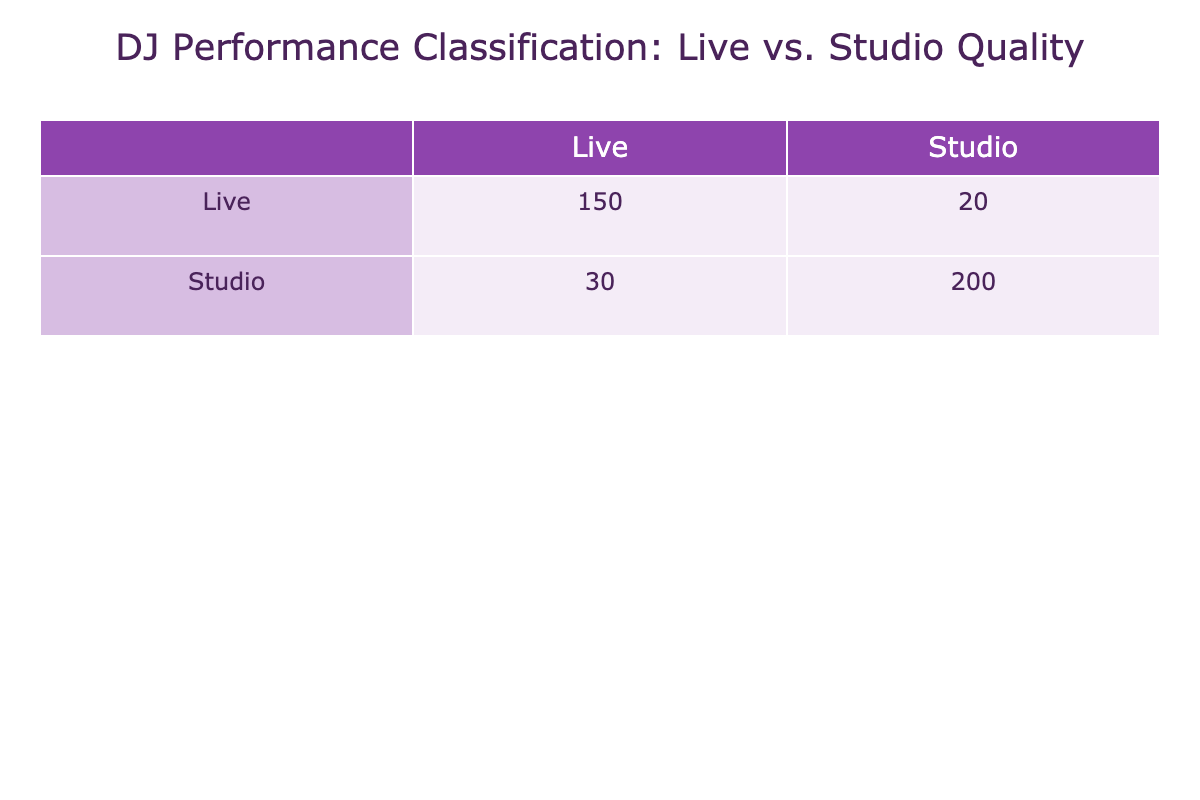What is the total number of predicted "Live" performances? To find the total predicted "Live" performances, we need to consider both the true positives (Live, Live) and false positives (Studio, Live). According to the table, Live predicted as Live has a count of 150, and Studio predicted as Live has a count of 20. Adding these together gives us 150 + 20 = 170.
Answer: 170 How many performances were correctly classified as "Studio"? The performances correctly classified as "Studio" refer to the true positives (Studio, Studio). From the table, we see that the count for this classification is 200.
Answer: 200 What is the total number of performances classified as "Live"? To calculate the total classified as "Live", we add the counts for both Live and Studio predicted as Live. The counts are 150 for Live, Live and 20 for Studio, Live, totaling 150 + 20 = 170.
Answer: 170 Is the number of true negatives higher than false negatives? True negatives are the counts of Studio predicted as Studio, which is 200, while false negatives are the counts of Live predicted as Studio, which is 30. Since 200 is greater than 30, the answer is yes.
Answer: Yes What percentage of performances were misclassified as "Live"? To determine the percentage misclassified as Live, we need to identify the total misclassifications. This includes Studio classified as Live (20) and Live classified as Studio (30). Therefore, the total misclassifications are 20 + 30 = 50. The total performances is 150 + 30 + 20 + 200 = 400. The percentage misclassified is (50 / 400) * 100 = 12.5%.
Answer: 12.5% What is the ratio of true positives to false positives for "Live" classifications? True positives for "Live" classifications is the count of Live predicted as Live, which is 150. False positives is the count of Studio predicted as Live, which is 20. The ratio therefore is 150 / 20, simplifying this gives us 7.5.
Answer: 7.5 How many more performances were classified as "Studio" compared to those predicted as "Live"? Total classified as Studio includes the counts for Studio, Studio (200) and Live, Studio (30). The total count for Studio classifications is 200 + 30 = 230. The total classified as Live (from previous question) is 170. Therefore, 230 - 170 = 60.
Answer: 60 Is it true that more performers were misclassified into Studio than Live? To evaluate this, we compare the counts: Studio predicted as Live (20) and Live predicted as Studio (30). Since 30 is greater than 20, it is true that more were misclassified into Studio than Live.
Answer: Yes What is the total number of observed performances reflected in the table? To find the observed performances, add up all counts: Live, Live (150) + Live, Studio (30) + Studio, Live (20) + Studio, Studio (200) = 150 + 30 + 20 + 200 = 400.
Answer: 400 